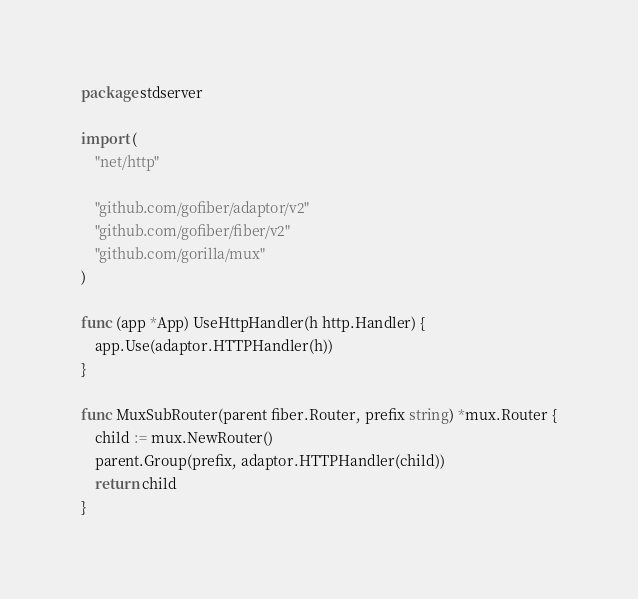<code> <loc_0><loc_0><loc_500><loc_500><_Go_>package stdserver

import (
	"net/http"

	"github.com/gofiber/adaptor/v2"
	"github.com/gofiber/fiber/v2"
	"github.com/gorilla/mux"
)

func (app *App) UseHttpHandler(h http.Handler) {
	app.Use(adaptor.HTTPHandler(h))
}

func MuxSubRouter(parent fiber.Router, prefix string) *mux.Router {
	child := mux.NewRouter()
	parent.Group(prefix, adaptor.HTTPHandler(child))
	return child
}
</code> 